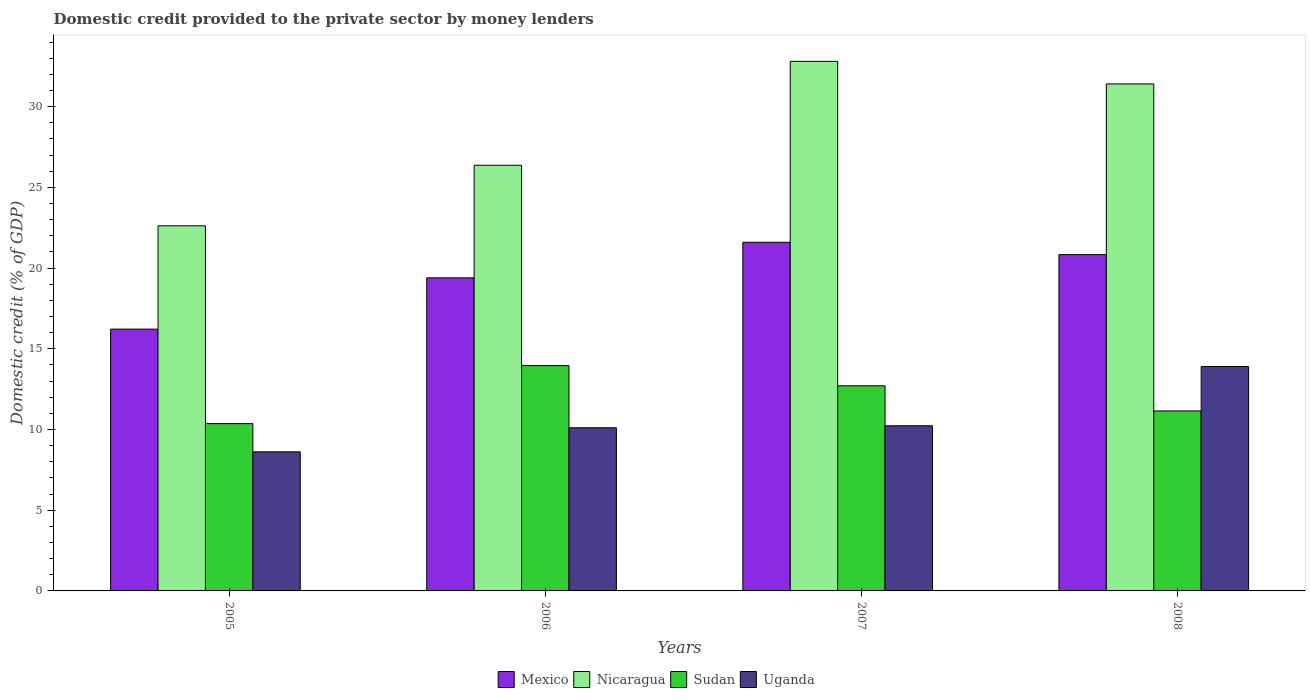Are the number of bars on each tick of the X-axis equal?
Your response must be concise. Yes. How many bars are there on the 4th tick from the right?
Ensure brevity in your answer.  4. In how many cases, is the number of bars for a given year not equal to the number of legend labels?
Your answer should be compact. 0. What is the domestic credit provided to the private sector by money lenders in Sudan in 2007?
Offer a terse response. 12.71. Across all years, what is the maximum domestic credit provided to the private sector by money lenders in Uganda?
Make the answer very short. 13.9. Across all years, what is the minimum domestic credit provided to the private sector by money lenders in Mexico?
Make the answer very short. 16.22. What is the total domestic credit provided to the private sector by money lenders in Nicaragua in the graph?
Make the answer very short. 113.21. What is the difference between the domestic credit provided to the private sector by money lenders in Sudan in 2006 and that in 2007?
Your answer should be very brief. 1.25. What is the difference between the domestic credit provided to the private sector by money lenders in Mexico in 2007 and the domestic credit provided to the private sector by money lenders in Nicaragua in 2005?
Provide a succinct answer. -1.02. What is the average domestic credit provided to the private sector by money lenders in Sudan per year?
Offer a terse response. 12.05. In the year 2008, what is the difference between the domestic credit provided to the private sector by money lenders in Mexico and domestic credit provided to the private sector by money lenders in Sudan?
Your answer should be compact. 9.68. In how many years, is the domestic credit provided to the private sector by money lenders in Nicaragua greater than 11 %?
Keep it short and to the point. 4. What is the ratio of the domestic credit provided to the private sector by money lenders in Mexico in 2006 to that in 2007?
Your response must be concise. 0.9. Is the difference between the domestic credit provided to the private sector by money lenders in Mexico in 2005 and 2006 greater than the difference between the domestic credit provided to the private sector by money lenders in Sudan in 2005 and 2006?
Provide a short and direct response. Yes. What is the difference between the highest and the second highest domestic credit provided to the private sector by money lenders in Mexico?
Ensure brevity in your answer.  0.76. What is the difference between the highest and the lowest domestic credit provided to the private sector by money lenders in Sudan?
Keep it short and to the point. 3.6. In how many years, is the domestic credit provided to the private sector by money lenders in Uganda greater than the average domestic credit provided to the private sector by money lenders in Uganda taken over all years?
Provide a short and direct response. 1. Is the sum of the domestic credit provided to the private sector by money lenders in Mexico in 2005 and 2006 greater than the maximum domestic credit provided to the private sector by money lenders in Uganda across all years?
Ensure brevity in your answer.  Yes. What does the 4th bar from the left in 2006 represents?
Provide a short and direct response. Uganda. What does the 3rd bar from the right in 2007 represents?
Your answer should be compact. Nicaragua. Is it the case that in every year, the sum of the domestic credit provided to the private sector by money lenders in Uganda and domestic credit provided to the private sector by money lenders in Nicaragua is greater than the domestic credit provided to the private sector by money lenders in Sudan?
Your answer should be compact. Yes. How many years are there in the graph?
Ensure brevity in your answer.  4. Does the graph contain grids?
Ensure brevity in your answer.  No. How many legend labels are there?
Your answer should be very brief. 4. What is the title of the graph?
Offer a very short reply. Domestic credit provided to the private sector by money lenders. Does "Singapore" appear as one of the legend labels in the graph?
Provide a short and direct response. No. What is the label or title of the Y-axis?
Offer a very short reply. Domestic credit (% of GDP). What is the Domestic credit (% of GDP) of Mexico in 2005?
Ensure brevity in your answer.  16.22. What is the Domestic credit (% of GDP) of Nicaragua in 2005?
Provide a succinct answer. 22.62. What is the Domestic credit (% of GDP) of Sudan in 2005?
Offer a very short reply. 10.36. What is the Domestic credit (% of GDP) in Uganda in 2005?
Provide a short and direct response. 8.62. What is the Domestic credit (% of GDP) of Mexico in 2006?
Your answer should be very brief. 19.4. What is the Domestic credit (% of GDP) in Nicaragua in 2006?
Provide a succinct answer. 26.37. What is the Domestic credit (% of GDP) in Sudan in 2006?
Ensure brevity in your answer.  13.96. What is the Domestic credit (% of GDP) in Uganda in 2006?
Your answer should be very brief. 10.11. What is the Domestic credit (% of GDP) in Mexico in 2007?
Provide a short and direct response. 21.6. What is the Domestic credit (% of GDP) of Nicaragua in 2007?
Keep it short and to the point. 32.81. What is the Domestic credit (% of GDP) in Sudan in 2007?
Keep it short and to the point. 12.71. What is the Domestic credit (% of GDP) of Uganda in 2007?
Provide a succinct answer. 10.23. What is the Domestic credit (% of GDP) in Mexico in 2008?
Keep it short and to the point. 20.84. What is the Domestic credit (% of GDP) of Nicaragua in 2008?
Your response must be concise. 31.41. What is the Domestic credit (% of GDP) in Sudan in 2008?
Offer a very short reply. 11.15. What is the Domestic credit (% of GDP) in Uganda in 2008?
Provide a succinct answer. 13.9. Across all years, what is the maximum Domestic credit (% of GDP) in Mexico?
Offer a very short reply. 21.6. Across all years, what is the maximum Domestic credit (% of GDP) in Nicaragua?
Your response must be concise. 32.81. Across all years, what is the maximum Domestic credit (% of GDP) of Sudan?
Offer a very short reply. 13.96. Across all years, what is the maximum Domestic credit (% of GDP) of Uganda?
Your answer should be compact. 13.9. Across all years, what is the minimum Domestic credit (% of GDP) in Mexico?
Give a very brief answer. 16.22. Across all years, what is the minimum Domestic credit (% of GDP) of Nicaragua?
Offer a terse response. 22.62. Across all years, what is the minimum Domestic credit (% of GDP) in Sudan?
Offer a very short reply. 10.36. Across all years, what is the minimum Domestic credit (% of GDP) of Uganda?
Your answer should be compact. 8.62. What is the total Domestic credit (% of GDP) of Mexico in the graph?
Provide a succinct answer. 78.05. What is the total Domestic credit (% of GDP) in Nicaragua in the graph?
Your response must be concise. 113.21. What is the total Domestic credit (% of GDP) in Sudan in the graph?
Make the answer very short. 48.18. What is the total Domestic credit (% of GDP) of Uganda in the graph?
Offer a terse response. 42.86. What is the difference between the Domestic credit (% of GDP) of Mexico in 2005 and that in 2006?
Provide a succinct answer. -3.18. What is the difference between the Domestic credit (% of GDP) in Nicaragua in 2005 and that in 2006?
Offer a terse response. -3.75. What is the difference between the Domestic credit (% of GDP) in Sudan in 2005 and that in 2006?
Your answer should be very brief. -3.6. What is the difference between the Domestic credit (% of GDP) in Uganda in 2005 and that in 2006?
Your answer should be very brief. -1.49. What is the difference between the Domestic credit (% of GDP) in Mexico in 2005 and that in 2007?
Your answer should be very brief. -5.38. What is the difference between the Domestic credit (% of GDP) of Nicaragua in 2005 and that in 2007?
Your answer should be compact. -10.19. What is the difference between the Domestic credit (% of GDP) of Sudan in 2005 and that in 2007?
Offer a terse response. -2.34. What is the difference between the Domestic credit (% of GDP) in Uganda in 2005 and that in 2007?
Make the answer very short. -1.62. What is the difference between the Domestic credit (% of GDP) of Mexico in 2005 and that in 2008?
Keep it short and to the point. -4.62. What is the difference between the Domestic credit (% of GDP) in Nicaragua in 2005 and that in 2008?
Ensure brevity in your answer.  -8.79. What is the difference between the Domestic credit (% of GDP) of Sudan in 2005 and that in 2008?
Keep it short and to the point. -0.79. What is the difference between the Domestic credit (% of GDP) in Uganda in 2005 and that in 2008?
Keep it short and to the point. -5.29. What is the difference between the Domestic credit (% of GDP) in Mexico in 2006 and that in 2007?
Make the answer very short. -2.2. What is the difference between the Domestic credit (% of GDP) in Nicaragua in 2006 and that in 2007?
Offer a very short reply. -6.44. What is the difference between the Domestic credit (% of GDP) of Sudan in 2006 and that in 2007?
Make the answer very short. 1.25. What is the difference between the Domestic credit (% of GDP) of Uganda in 2006 and that in 2007?
Ensure brevity in your answer.  -0.12. What is the difference between the Domestic credit (% of GDP) in Mexico in 2006 and that in 2008?
Provide a short and direct response. -1.44. What is the difference between the Domestic credit (% of GDP) of Nicaragua in 2006 and that in 2008?
Provide a succinct answer. -5.04. What is the difference between the Domestic credit (% of GDP) in Sudan in 2006 and that in 2008?
Keep it short and to the point. 2.81. What is the difference between the Domestic credit (% of GDP) in Uganda in 2006 and that in 2008?
Your answer should be very brief. -3.79. What is the difference between the Domestic credit (% of GDP) in Mexico in 2007 and that in 2008?
Keep it short and to the point. 0.76. What is the difference between the Domestic credit (% of GDP) in Nicaragua in 2007 and that in 2008?
Ensure brevity in your answer.  1.4. What is the difference between the Domestic credit (% of GDP) in Sudan in 2007 and that in 2008?
Provide a short and direct response. 1.56. What is the difference between the Domestic credit (% of GDP) of Uganda in 2007 and that in 2008?
Make the answer very short. -3.67. What is the difference between the Domestic credit (% of GDP) of Mexico in 2005 and the Domestic credit (% of GDP) of Nicaragua in 2006?
Your answer should be very brief. -10.15. What is the difference between the Domestic credit (% of GDP) of Mexico in 2005 and the Domestic credit (% of GDP) of Sudan in 2006?
Offer a terse response. 2.26. What is the difference between the Domestic credit (% of GDP) of Mexico in 2005 and the Domestic credit (% of GDP) of Uganda in 2006?
Your answer should be very brief. 6.11. What is the difference between the Domestic credit (% of GDP) in Nicaragua in 2005 and the Domestic credit (% of GDP) in Sudan in 2006?
Your answer should be very brief. 8.66. What is the difference between the Domestic credit (% of GDP) in Nicaragua in 2005 and the Domestic credit (% of GDP) in Uganda in 2006?
Offer a very short reply. 12.51. What is the difference between the Domestic credit (% of GDP) in Sudan in 2005 and the Domestic credit (% of GDP) in Uganda in 2006?
Keep it short and to the point. 0.26. What is the difference between the Domestic credit (% of GDP) in Mexico in 2005 and the Domestic credit (% of GDP) in Nicaragua in 2007?
Make the answer very short. -16.59. What is the difference between the Domestic credit (% of GDP) in Mexico in 2005 and the Domestic credit (% of GDP) in Sudan in 2007?
Ensure brevity in your answer.  3.51. What is the difference between the Domestic credit (% of GDP) in Mexico in 2005 and the Domestic credit (% of GDP) in Uganda in 2007?
Your answer should be very brief. 5.99. What is the difference between the Domestic credit (% of GDP) in Nicaragua in 2005 and the Domestic credit (% of GDP) in Sudan in 2007?
Provide a short and direct response. 9.91. What is the difference between the Domestic credit (% of GDP) of Nicaragua in 2005 and the Domestic credit (% of GDP) of Uganda in 2007?
Make the answer very short. 12.39. What is the difference between the Domestic credit (% of GDP) in Sudan in 2005 and the Domestic credit (% of GDP) in Uganda in 2007?
Give a very brief answer. 0.13. What is the difference between the Domestic credit (% of GDP) in Mexico in 2005 and the Domestic credit (% of GDP) in Nicaragua in 2008?
Offer a very short reply. -15.19. What is the difference between the Domestic credit (% of GDP) in Mexico in 2005 and the Domestic credit (% of GDP) in Sudan in 2008?
Your response must be concise. 5.07. What is the difference between the Domestic credit (% of GDP) in Mexico in 2005 and the Domestic credit (% of GDP) in Uganda in 2008?
Offer a terse response. 2.32. What is the difference between the Domestic credit (% of GDP) of Nicaragua in 2005 and the Domestic credit (% of GDP) of Sudan in 2008?
Your response must be concise. 11.47. What is the difference between the Domestic credit (% of GDP) in Nicaragua in 2005 and the Domestic credit (% of GDP) in Uganda in 2008?
Your answer should be compact. 8.72. What is the difference between the Domestic credit (% of GDP) of Sudan in 2005 and the Domestic credit (% of GDP) of Uganda in 2008?
Give a very brief answer. -3.54. What is the difference between the Domestic credit (% of GDP) in Mexico in 2006 and the Domestic credit (% of GDP) in Nicaragua in 2007?
Make the answer very short. -13.41. What is the difference between the Domestic credit (% of GDP) of Mexico in 2006 and the Domestic credit (% of GDP) of Sudan in 2007?
Offer a very short reply. 6.69. What is the difference between the Domestic credit (% of GDP) in Mexico in 2006 and the Domestic credit (% of GDP) in Uganda in 2007?
Provide a succinct answer. 9.17. What is the difference between the Domestic credit (% of GDP) in Nicaragua in 2006 and the Domestic credit (% of GDP) in Sudan in 2007?
Provide a succinct answer. 13.67. What is the difference between the Domestic credit (% of GDP) in Nicaragua in 2006 and the Domestic credit (% of GDP) in Uganda in 2007?
Give a very brief answer. 16.14. What is the difference between the Domestic credit (% of GDP) in Sudan in 2006 and the Domestic credit (% of GDP) in Uganda in 2007?
Keep it short and to the point. 3.73. What is the difference between the Domestic credit (% of GDP) of Mexico in 2006 and the Domestic credit (% of GDP) of Nicaragua in 2008?
Your response must be concise. -12.01. What is the difference between the Domestic credit (% of GDP) of Mexico in 2006 and the Domestic credit (% of GDP) of Sudan in 2008?
Provide a short and direct response. 8.24. What is the difference between the Domestic credit (% of GDP) of Mexico in 2006 and the Domestic credit (% of GDP) of Uganda in 2008?
Ensure brevity in your answer.  5.5. What is the difference between the Domestic credit (% of GDP) in Nicaragua in 2006 and the Domestic credit (% of GDP) in Sudan in 2008?
Your answer should be very brief. 15.22. What is the difference between the Domestic credit (% of GDP) of Nicaragua in 2006 and the Domestic credit (% of GDP) of Uganda in 2008?
Ensure brevity in your answer.  12.47. What is the difference between the Domestic credit (% of GDP) in Sudan in 2006 and the Domestic credit (% of GDP) in Uganda in 2008?
Offer a terse response. 0.06. What is the difference between the Domestic credit (% of GDP) of Mexico in 2007 and the Domestic credit (% of GDP) of Nicaragua in 2008?
Provide a short and direct response. -9.81. What is the difference between the Domestic credit (% of GDP) in Mexico in 2007 and the Domestic credit (% of GDP) in Sudan in 2008?
Offer a terse response. 10.45. What is the difference between the Domestic credit (% of GDP) in Mexico in 2007 and the Domestic credit (% of GDP) in Uganda in 2008?
Your answer should be compact. 7.7. What is the difference between the Domestic credit (% of GDP) in Nicaragua in 2007 and the Domestic credit (% of GDP) in Sudan in 2008?
Provide a succinct answer. 21.66. What is the difference between the Domestic credit (% of GDP) in Nicaragua in 2007 and the Domestic credit (% of GDP) in Uganda in 2008?
Your response must be concise. 18.91. What is the difference between the Domestic credit (% of GDP) of Sudan in 2007 and the Domestic credit (% of GDP) of Uganda in 2008?
Make the answer very short. -1.19. What is the average Domestic credit (% of GDP) in Mexico per year?
Offer a terse response. 19.51. What is the average Domestic credit (% of GDP) in Nicaragua per year?
Make the answer very short. 28.3. What is the average Domestic credit (% of GDP) in Sudan per year?
Ensure brevity in your answer.  12.05. What is the average Domestic credit (% of GDP) of Uganda per year?
Your answer should be compact. 10.71. In the year 2005, what is the difference between the Domestic credit (% of GDP) of Mexico and Domestic credit (% of GDP) of Nicaragua?
Ensure brevity in your answer.  -6.4. In the year 2005, what is the difference between the Domestic credit (% of GDP) in Mexico and Domestic credit (% of GDP) in Sudan?
Provide a short and direct response. 5.86. In the year 2005, what is the difference between the Domestic credit (% of GDP) in Mexico and Domestic credit (% of GDP) in Uganda?
Offer a very short reply. 7.6. In the year 2005, what is the difference between the Domestic credit (% of GDP) of Nicaragua and Domestic credit (% of GDP) of Sudan?
Give a very brief answer. 12.26. In the year 2005, what is the difference between the Domestic credit (% of GDP) of Nicaragua and Domestic credit (% of GDP) of Uganda?
Offer a terse response. 14. In the year 2005, what is the difference between the Domestic credit (% of GDP) in Sudan and Domestic credit (% of GDP) in Uganda?
Ensure brevity in your answer.  1.75. In the year 2006, what is the difference between the Domestic credit (% of GDP) in Mexico and Domestic credit (% of GDP) in Nicaragua?
Offer a very short reply. -6.98. In the year 2006, what is the difference between the Domestic credit (% of GDP) of Mexico and Domestic credit (% of GDP) of Sudan?
Give a very brief answer. 5.44. In the year 2006, what is the difference between the Domestic credit (% of GDP) of Mexico and Domestic credit (% of GDP) of Uganda?
Provide a succinct answer. 9.29. In the year 2006, what is the difference between the Domestic credit (% of GDP) of Nicaragua and Domestic credit (% of GDP) of Sudan?
Your answer should be very brief. 12.41. In the year 2006, what is the difference between the Domestic credit (% of GDP) of Nicaragua and Domestic credit (% of GDP) of Uganda?
Your response must be concise. 16.26. In the year 2006, what is the difference between the Domestic credit (% of GDP) in Sudan and Domestic credit (% of GDP) in Uganda?
Offer a terse response. 3.85. In the year 2007, what is the difference between the Domestic credit (% of GDP) of Mexico and Domestic credit (% of GDP) of Nicaragua?
Your response must be concise. -11.21. In the year 2007, what is the difference between the Domestic credit (% of GDP) in Mexico and Domestic credit (% of GDP) in Sudan?
Offer a terse response. 8.89. In the year 2007, what is the difference between the Domestic credit (% of GDP) in Mexico and Domestic credit (% of GDP) in Uganda?
Offer a terse response. 11.37. In the year 2007, what is the difference between the Domestic credit (% of GDP) in Nicaragua and Domestic credit (% of GDP) in Sudan?
Ensure brevity in your answer.  20.1. In the year 2007, what is the difference between the Domestic credit (% of GDP) in Nicaragua and Domestic credit (% of GDP) in Uganda?
Your answer should be very brief. 22.58. In the year 2007, what is the difference between the Domestic credit (% of GDP) in Sudan and Domestic credit (% of GDP) in Uganda?
Your answer should be compact. 2.48. In the year 2008, what is the difference between the Domestic credit (% of GDP) of Mexico and Domestic credit (% of GDP) of Nicaragua?
Your answer should be very brief. -10.57. In the year 2008, what is the difference between the Domestic credit (% of GDP) in Mexico and Domestic credit (% of GDP) in Sudan?
Provide a short and direct response. 9.68. In the year 2008, what is the difference between the Domestic credit (% of GDP) of Mexico and Domestic credit (% of GDP) of Uganda?
Your answer should be very brief. 6.94. In the year 2008, what is the difference between the Domestic credit (% of GDP) of Nicaragua and Domestic credit (% of GDP) of Sudan?
Provide a succinct answer. 20.26. In the year 2008, what is the difference between the Domestic credit (% of GDP) of Nicaragua and Domestic credit (% of GDP) of Uganda?
Provide a short and direct response. 17.51. In the year 2008, what is the difference between the Domestic credit (% of GDP) in Sudan and Domestic credit (% of GDP) in Uganda?
Ensure brevity in your answer.  -2.75. What is the ratio of the Domestic credit (% of GDP) of Mexico in 2005 to that in 2006?
Give a very brief answer. 0.84. What is the ratio of the Domestic credit (% of GDP) of Nicaragua in 2005 to that in 2006?
Your answer should be compact. 0.86. What is the ratio of the Domestic credit (% of GDP) in Sudan in 2005 to that in 2006?
Your response must be concise. 0.74. What is the ratio of the Domestic credit (% of GDP) in Uganda in 2005 to that in 2006?
Your response must be concise. 0.85. What is the ratio of the Domestic credit (% of GDP) of Mexico in 2005 to that in 2007?
Keep it short and to the point. 0.75. What is the ratio of the Domestic credit (% of GDP) of Nicaragua in 2005 to that in 2007?
Ensure brevity in your answer.  0.69. What is the ratio of the Domestic credit (% of GDP) of Sudan in 2005 to that in 2007?
Your answer should be compact. 0.82. What is the ratio of the Domestic credit (% of GDP) in Uganda in 2005 to that in 2007?
Provide a short and direct response. 0.84. What is the ratio of the Domestic credit (% of GDP) in Mexico in 2005 to that in 2008?
Your response must be concise. 0.78. What is the ratio of the Domestic credit (% of GDP) of Nicaragua in 2005 to that in 2008?
Your answer should be very brief. 0.72. What is the ratio of the Domestic credit (% of GDP) of Sudan in 2005 to that in 2008?
Your answer should be very brief. 0.93. What is the ratio of the Domestic credit (% of GDP) of Uganda in 2005 to that in 2008?
Ensure brevity in your answer.  0.62. What is the ratio of the Domestic credit (% of GDP) of Mexico in 2006 to that in 2007?
Ensure brevity in your answer.  0.9. What is the ratio of the Domestic credit (% of GDP) in Nicaragua in 2006 to that in 2007?
Your response must be concise. 0.8. What is the ratio of the Domestic credit (% of GDP) of Sudan in 2006 to that in 2007?
Provide a short and direct response. 1.1. What is the ratio of the Domestic credit (% of GDP) of Uganda in 2006 to that in 2007?
Your answer should be very brief. 0.99. What is the ratio of the Domestic credit (% of GDP) in Mexico in 2006 to that in 2008?
Ensure brevity in your answer.  0.93. What is the ratio of the Domestic credit (% of GDP) in Nicaragua in 2006 to that in 2008?
Provide a short and direct response. 0.84. What is the ratio of the Domestic credit (% of GDP) in Sudan in 2006 to that in 2008?
Offer a very short reply. 1.25. What is the ratio of the Domestic credit (% of GDP) in Uganda in 2006 to that in 2008?
Provide a short and direct response. 0.73. What is the ratio of the Domestic credit (% of GDP) of Mexico in 2007 to that in 2008?
Your response must be concise. 1.04. What is the ratio of the Domestic credit (% of GDP) of Nicaragua in 2007 to that in 2008?
Your answer should be compact. 1.04. What is the ratio of the Domestic credit (% of GDP) of Sudan in 2007 to that in 2008?
Offer a very short reply. 1.14. What is the ratio of the Domestic credit (% of GDP) in Uganda in 2007 to that in 2008?
Offer a very short reply. 0.74. What is the difference between the highest and the second highest Domestic credit (% of GDP) in Mexico?
Provide a succinct answer. 0.76. What is the difference between the highest and the second highest Domestic credit (% of GDP) of Nicaragua?
Make the answer very short. 1.4. What is the difference between the highest and the second highest Domestic credit (% of GDP) of Sudan?
Keep it short and to the point. 1.25. What is the difference between the highest and the second highest Domestic credit (% of GDP) in Uganda?
Your answer should be very brief. 3.67. What is the difference between the highest and the lowest Domestic credit (% of GDP) of Mexico?
Give a very brief answer. 5.38. What is the difference between the highest and the lowest Domestic credit (% of GDP) of Nicaragua?
Offer a terse response. 10.19. What is the difference between the highest and the lowest Domestic credit (% of GDP) in Sudan?
Your answer should be very brief. 3.6. What is the difference between the highest and the lowest Domestic credit (% of GDP) in Uganda?
Your answer should be compact. 5.29. 